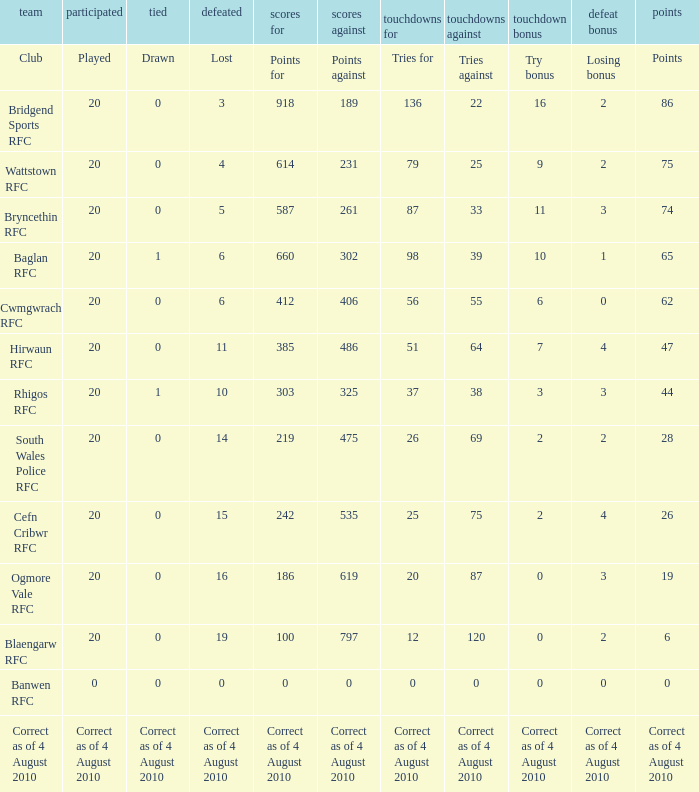What is the points against when drawn is drawn? Points against. 